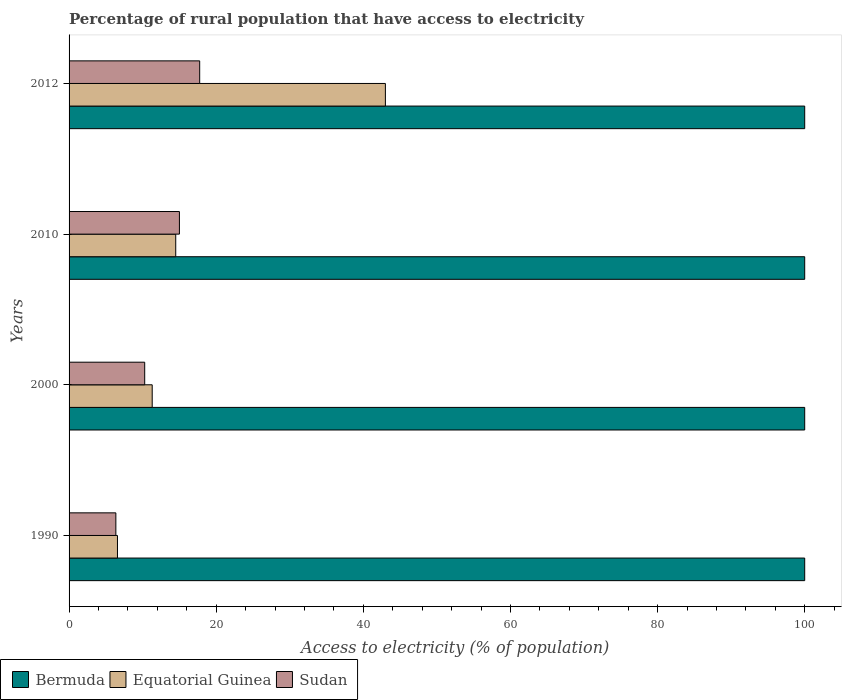How many different coloured bars are there?
Offer a very short reply. 3. Are the number of bars per tick equal to the number of legend labels?
Provide a succinct answer. Yes. Are the number of bars on each tick of the Y-axis equal?
Keep it short and to the point. Yes. How many bars are there on the 4th tick from the top?
Offer a very short reply. 3. What is the percentage of rural population that have access to electricity in Equatorial Guinea in 2000?
Keep it short and to the point. 11.3. Across all years, what is the maximum percentage of rural population that have access to electricity in Bermuda?
Your answer should be very brief. 100. Across all years, what is the minimum percentage of rural population that have access to electricity in Sudan?
Give a very brief answer. 6.36. In which year was the percentage of rural population that have access to electricity in Equatorial Guinea maximum?
Make the answer very short. 2012. In which year was the percentage of rural population that have access to electricity in Bermuda minimum?
Make the answer very short. 1990. What is the total percentage of rural population that have access to electricity in Sudan in the graph?
Your response must be concise. 49.4. What is the difference between the percentage of rural population that have access to electricity in Equatorial Guinea in 2000 and that in 2010?
Offer a very short reply. -3.2. What is the difference between the percentage of rural population that have access to electricity in Equatorial Guinea in 1990 and the percentage of rural population that have access to electricity in Bermuda in 2012?
Offer a very short reply. -93.42. What is the average percentage of rural population that have access to electricity in Sudan per year?
Offer a terse response. 12.35. In the year 2010, what is the difference between the percentage of rural population that have access to electricity in Sudan and percentage of rural population that have access to electricity in Bermuda?
Ensure brevity in your answer.  -85. What is the ratio of the percentage of rural population that have access to electricity in Bermuda in 2010 to that in 2012?
Provide a succinct answer. 1. Is the percentage of rural population that have access to electricity in Equatorial Guinea in 2000 less than that in 2012?
Make the answer very short. Yes. Is the difference between the percentage of rural population that have access to electricity in Sudan in 2000 and 2012 greater than the difference between the percentage of rural population that have access to electricity in Bermuda in 2000 and 2012?
Your answer should be compact. No. What is the difference between the highest and the second highest percentage of rural population that have access to electricity in Equatorial Guinea?
Give a very brief answer. 28.5. What is the difference between the highest and the lowest percentage of rural population that have access to electricity in Sudan?
Provide a succinct answer. 11.39. In how many years, is the percentage of rural population that have access to electricity in Sudan greater than the average percentage of rural population that have access to electricity in Sudan taken over all years?
Provide a short and direct response. 2. What does the 3rd bar from the top in 1990 represents?
Offer a very short reply. Bermuda. What does the 3rd bar from the bottom in 2012 represents?
Your answer should be very brief. Sudan. Is it the case that in every year, the sum of the percentage of rural population that have access to electricity in Sudan and percentage of rural population that have access to electricity in Equatorial Guinea is greater than the percentage of rural population that have access to electricity in Bermuda?
Your answer should be very brief. No. How many bars are there?
Keep it short and to the point. 12. How many years are there in the graph?
Provide a succinct answer. 4. Are the values on the major ticks of X-axis written in scientific E-notation?
Offer a terse response. No. Does the graph contain grids?
Offer a very short reply. No. Where does the legend appear in the graph?
Your answer should be compact. Bottom left. How many legend labels are there?
Your response must be concise. 3. What is the title of the graph?
Your response must be concise. Percentage of rural population that have access to electricity. Does "Andorra" appear as one of the legend labels in the graph?
Provide a succinct answer. No. What is the label or title of the X-axis?
Ensure brevity in your answer.  Access to electricity (% of population). What is the label or title of the Y-axis?
Provide a succinct answer. Years. What is the Access to electricity (% of population) in Equatorial Guinea in 1990?
Your answer should be very brief. 6.58. What is the Access to electricity (% of population) of Sudan in 1990?
Offer a terse response. 6.36. What is the Access to electricity (% of population) of Equatorial Guinea in 2000?
Provide a succinct answer. 11.3. What is the Access to electricity (% of population) of Sudan in 2000?
Provide a short and direct response. 10.28. What is the Access to electricity (% of population) in Equatorial Guinea in 2010?
Your answer should be very brief. 14.5. What is the Access to electricity (% of population) in Sudan in 2010?
Offer a terse response. 15. What is the Access to electricity (% of population) of Equatorial Guinea in 2012?
Offer a terse response. 43. What is the Access to electricity (% of population) in Sudan in 2012?
Give a very brief answer. 17.75. Across all years, what is the maximum Access to electricity (% of population) in Bermuda?
Provide a short and direct response. 100. Across all years, what is the maximum Access to electricity (% of population) of Sudan?
Your answer should be compact. 17.75. Across all years, what is the minimum Access to electricity (% of population) of Bermuda?
Your response must be concise. 100. Across all years, what is the minimum Access to electricity (% of population) of Equatorial Guinea?
Your response must be concise. 6.58. Across all years, what is the minimum Access to electricity (% of population) of Sudan?
Your response must be concise. 6.36. What is the total Access to electricity (% of population) in Bermuda in the graph?
Your response must be concise. 400. What is the total Access to electricity (% of population) of Equatorial Guinea in the graph?
Offer a terse response. 75.38. What is the total Access to electricity (% of population) in Sudan in the graph?
Give a very brief answer. 49.4. What is the difference between the Access to electricity (% of population) of Equatorial Guinea in 1990 and that in 2000?
Offer a very short reply. -4.72. What is the difference between the Access to electricity (% of population) in Sudan in 1990 and that in 2000?
Give a very brief answer. -3.92. What is the difference between the Access to electricity (% of population) of Bermuda in 1990 and that in 2010?
Give a very brief answer. 0. What is the difference between the Access to electricity (% of population) in Equatorial Guinea in 1990 and that in 2010?
Provide a succinct answer. -7.92. What is the difference between the Access to electricity (% of population) of Sudan in 1990 and that in 2010?
Make the answer very short. -8.64. What is the difference between the Access to electricity (% of population) in Equatorial Guinea in 1990 and that in 2012?
Ensure brevity in your answer.  -36.42. What is the difference between the Access to electricity (% of population) of Sudan in 1990 and that in 2012?
Keep it short and to the point. -11.39. What is the difference between the Access to electricity (% of population) in Equatorial Guinea in 2000 and that in 2010?
Keep it short and to the point. -3.2. What is the difference between the Access to electricity (% of population) of Sudan in 2000 and that in 2010?
Give a very brief answer. -4.72. What is the difference between the Access to electricity (% of population) in Equatorial Guinea in 2000 and that in 2012?
Provide a succinct answer. -31.7. What is the difference between the Access to electricity (% of population) in Sudan in 2000 and that in 2012?
Your answer should be compact. -7.47. What is the difference between the Access to electricity (% of population) of Equatorial Guinea in 2010 and that in 2012?
Offer a very short reply. -28.5. What is the difference between the Access to electricity (% of population) in Sudan in 2010 and that in 2012?
Your answer should be very brief. -2.75. What is the difference between the Access to electricity (% of population) in Bermuda in 1990 and the Access to electricity (% of population) in Equatorial Guinea in 2000?
Your answer should be compact. 88.7. What is the difference between the Access to electricity (% of population) of Bermuda in 1990 and the Access to electricity (% of population) of Sudan in 2000?
Make the answer very short. 89.72. What is the difference between the Access to electricity (% of population) in Equatorial Guinea in 1990 and the Access to electricity (% of population) in Sudan in 2000?
Give a very brief answer. -3.7. What is the difference between the Access to electricity (% of population) in Bermuda in 1990 and the Access to electricity (% of population) in Equatorial Guinea in 2010?
Your answer should be compact. 85.5. What is the difference between the Access to electricity (% of population) of Equatorial Guinea in 1990 and the Access to electricity (% of population) of Sudan in 2010?
Ensure brevity in your answer.  -8.42. What is the difference between the Access to electricity (% of population) of Bermuda in 1990 and the Access to electricity (% of population) of Sudan in 2012?
Your response must be concise. 82.25. What is the difference between the Access to electricity (% of population) of Equatorial Guinea in 1990 and the Access to electricity (% of population) of Sudan in 2012?
Provide a succinct answer. -11.18. What is the difference between the Access to electricity (% of population) of Bermuda in 2000 and the Access to electricity (% of population) of Equatorial Guinea in 2010?
Your response must be concise. 85.5. What is the difference between the Access to electricity (% of population) of Equatorial Guinea in 2000 and the Access to electricity (% of population) of Sudan in 2010?
Your response must be concise. -3.7. What is the difference between the Access to electricity (% of population) in Bermuda in 2000 and the Access to electricity (% of population) in Equatorial Guinea in 2012?
Your answer should be very brief. 57. What is the difference between the Access to electricity (% of population) in Bermuda in 2000 and the Access to electricity (% of population) in Sudan in 2012?
Give a very brief answer. 82.25. What is the difference between the Access to electricity (% of population) of Equatorial Guinea in 2000 and the Access to electricity (% of population) of Sudan in 2012?
Keep it short and to the point. -6.45. What is the difference between the Access to electricity (% of population) of Bermuda in 2010 and the Access to electricity (% of population) of Sudan in 2012?
Give a very brief answer. 82.25. What is the difference between the Access to electricity (% of population) of Equatorial Guinea in 2010 and the Access to electricity (% of population) of Sudan in 2012?
Offer a very short reply. -3.25. What is the average Access to electricity (% of population) of Bermuda per year?
Offer a very short reply. 100. What is the average Access to electricity (% of population) of Equatorial Guinea per year?
Your answer should be very brief. 18.85. What is the average Access to electricity (% of population) of Sudan per year?
Offer a terse response. 12.35. In the year 1990, what is the difference between the Access to electricity (% of population) in Bermuda and Access to electricity (% of population) in Equatorial Guinea?
Your response must be concise. 93.42. In the year 1990, what is the difference between the Access to electricity (% of population) of Bermuda and Access to electricity (% of population) of Sudan?
Your answer should be very brief. 93.64. In the year 1990, what is the difference between the Access to electricity (% of population) in Equatorial Guinea and Access to electricity (% of population) in Sudan?
Provide a succinct answer. 0.22. In the year 2000, what is the difference between the Access to electricity (% of population) in Bermuda and Access to electricity (% of population) in Equatorial Guinea?
Your answer should be very brief. 88.7. In the year 2000, what is the difference between the Access to electricity (% of population) of Bermuda and Access to electricity (% of population) of Sudan?
Make the answer very short. 89.72. In the year 2000, what is the difference between the Access to electricity (% of population) of Equatorial Guinea and Access to electricity (% of population) of Sudan?
Your response must be concise. 1.02. In the year 2010, what is the difference between the Access to electricity (% of population) in Bermuda and Access to electricity (% of population) in Equatorial Guinea?
Your response must be concise. 85.5. In the year 2012, what is the difference between the Access to electricity (% of population) in Bermuda and Access to electricity (% of population) in Equatorial Guinea?
Provide a succinct answer. 57. In the year 2012, what is the difference between the Access to electricity (% of population) in Bermuda and Access to electricity (% of population) in Sudan?
Ensure brevity in your answer.  82.25. In the year 2012, what is the difference between the Access to electricity (% of population) of Equatorial Guinea and Access to electricity (% of population) of Sudan?
Offer a terse response. 25.25. What is the ratio of the Access to electricity (% of population) of Bermuda in 1990 to that in 2000?
Make the answer very short. 1. What is the ratio of the Access to electricity (% of population) in Equatorial Guinea in 1990 to that in 2000?
Your response must be concise. 0.58. What is the ratio of the Access to electricity (% of population) of Sudan in 1990 to that in 2000?
Offer a very short reply. 0.62. What is the ratio of the Access to electricity (% of population) of Equatorial Guinea in 1990 to that in 2010?
Offer a terse response. 0.45. What is the ratio of the Access to electricity (% of population) in Sudan in 1990 to that in 2010?
Give a very brief answer. 0.42. What is the ratio of the Access to electricity (% of population) in Bermuda in 1990 to that in 2012?
Your response must be concise. 1. What is the ratio of the Access to electricity (% of population) in Equatorial Guinea in 1990 to that in 2012?
Keep it short and to the point. 0.15. What is the ratio of the Access to electricity (% of population) in Sudan in 1990 to that in 2012?
Make the answer very short. 0.36. What is the ratio of the Access to electricity (% of population) of Bermuda in 2000 to that in 2010?
Provide a short and direct response. 1. What is the ratio of the Access to electricity (% of population) in Equatorial Guinea in 2000 to that in 2010?
Provide a succinct answer. 0.78. What is the ratio of the Access to electricity (% of population) in Sudan in 2000 to that in 2010?
Give a very brief answer. 0.69. What is the ratio of the Access to electricity (% of population) in Bermuda in 2000 to that in 2012?
Keep it short and to the point. 1. What is the ratio of the Access to electricity (% of population) in Equatorial Guinea in 2000 to that in 2012?
Give a very brief answer. 0.26. What is the ratio of the Access to electricity (% of population) in Sudan in 2000 to that in 2012?
Offer a terse response. 0.58. What is the ratio of the Access to electricity (% of population) of Bermuda in 2010 to that in 2012?
Offer a terse response. 1. What is the ratio of the Access to electricity (% of population) in Equatorial Guinea in 2010 to that in 2012?
Make the answer very short. 0.34. What is the ratio of the Access to electricity (% of population) in Sudan in 2010 to that in 2012?
Offer a very short reply. 0.84. What is the difference between the highest and the second highest Access to electricity (% of population) of Bermuda?
Provide a short and direct response. 0. What is the difference between the highest and the second highest Access to electricity (% of population) of Equatorial Guinea?
Provide a succinct answer. 28.5. What is the difference between the highest and the second highest Access to electricity (% of population) in Sudan?
Your answer should be very brief. 2.75. What is the difference between the highest and the lowest Access to electricity (% of population) in Bermuda?
Make the answer very short. 0. What is the difference between the highest and the lowest Access to electricity (% of population) in Equatorial Guinea?
Provide a succinct answer. 36.42. What is the difference between the highest and the lowest Access to electricity (% of population) of Sudan?
Your answer should be very brief. 11.39. 